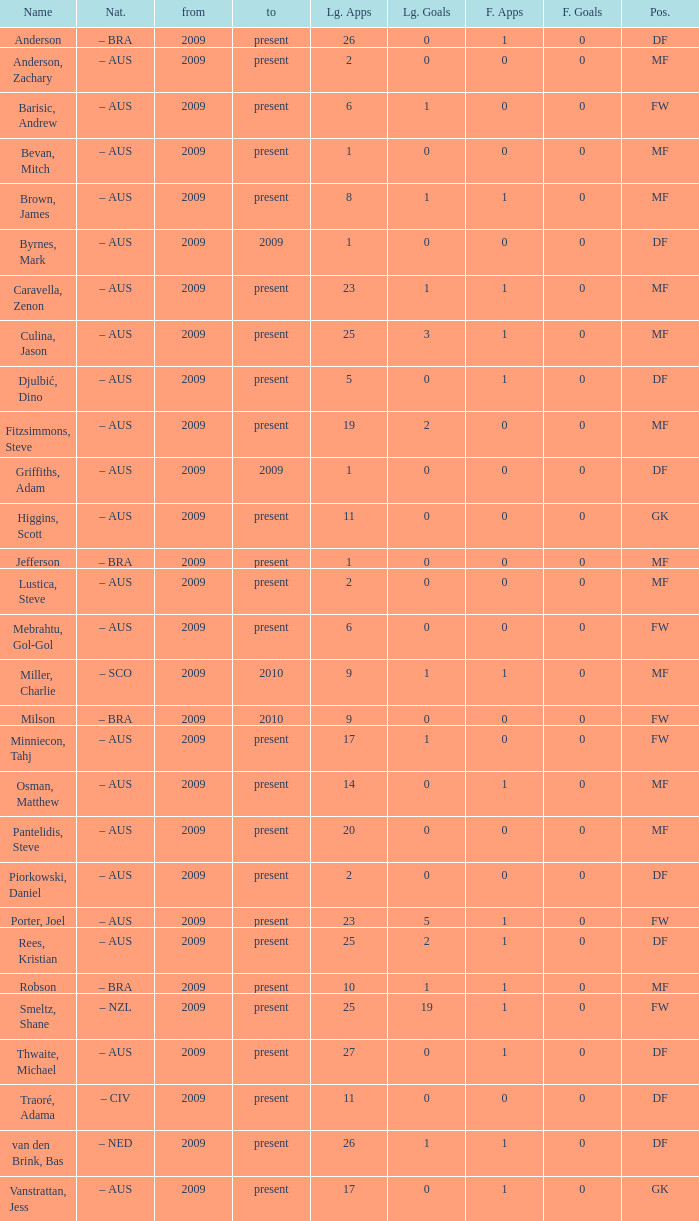Identify the top 19 league applications Present. 